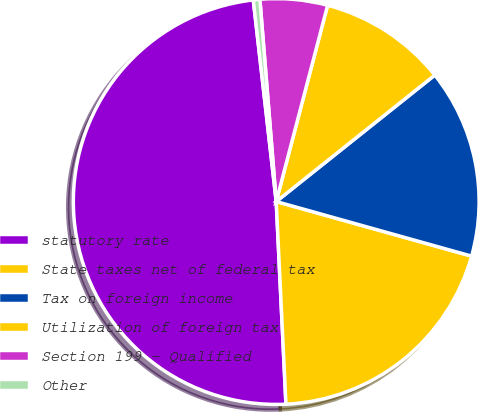Convert chart. <chart><loc_0><loc_0><loc_500><loc_500><pie_chart><fcel>statutory rate<fcel>State taxes net of federal tax<fcel>Tax on foreign income<fcel>Utilization of foreign tax<fcel>Section 199 - Qualified<fcel>Other<nl><fcel>48.96%<fcel>19.9%<fcel>15.05%<fcel>10.21%<fcel>5.36%<fcel>0.52%<nl></chart> 